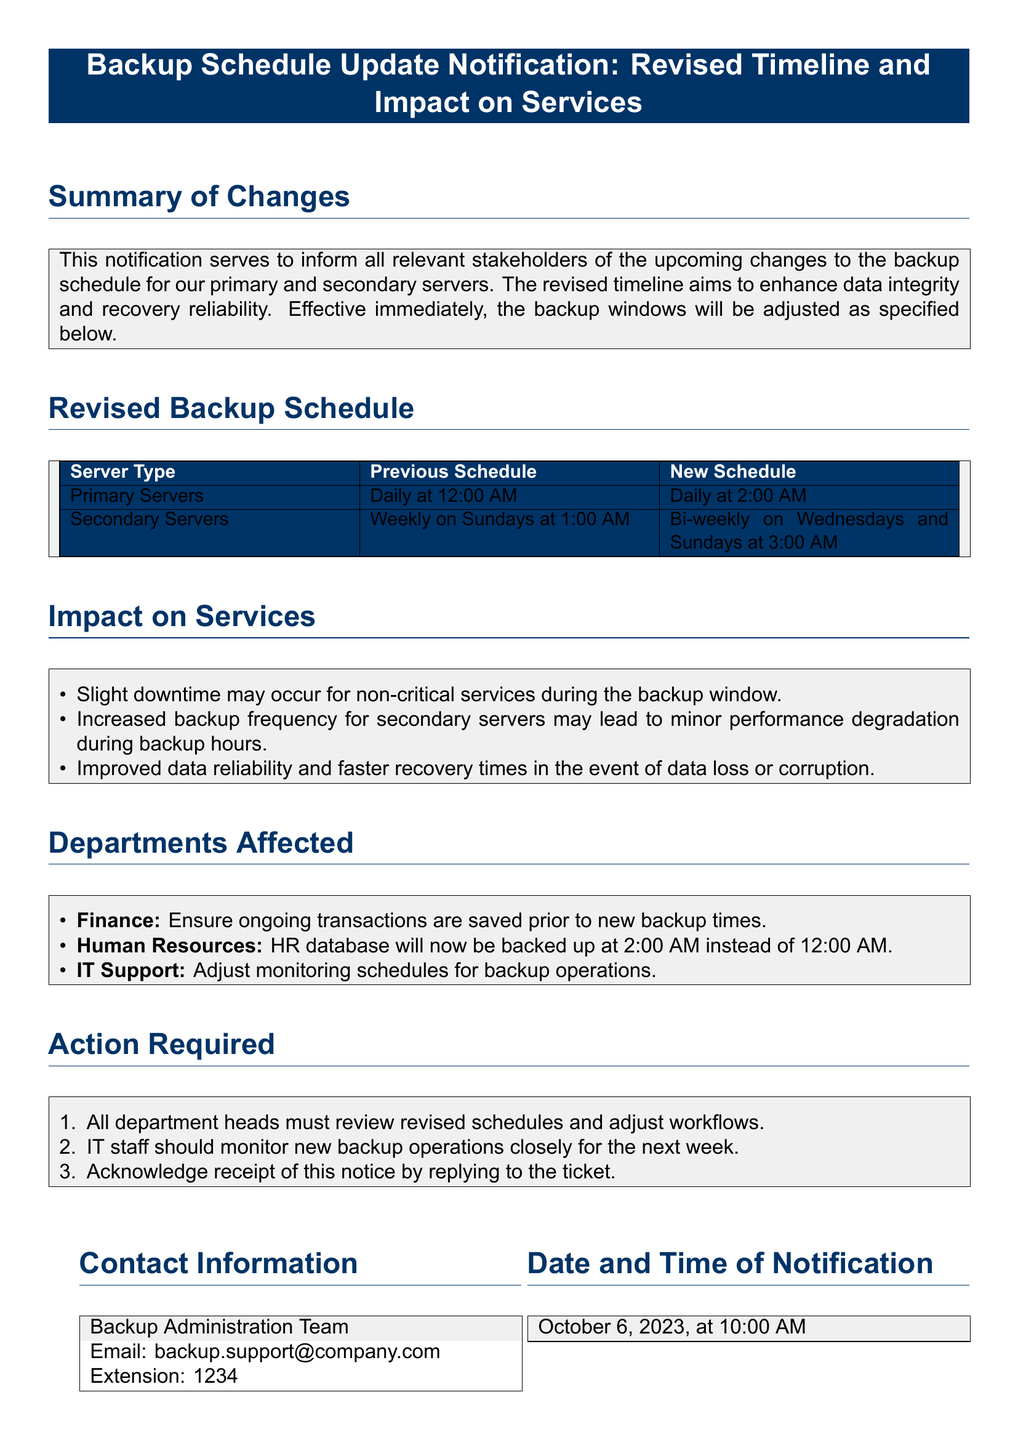What is the new backup time for primary servers? The new backup time for primary servers is adjusted from 12:00 AM to 2:00 AM.
Answer: Daily at 2:00 AM What is the revised backup frequency for secondary servers? Secondary servers will now back up bi-weekly on Wednesdays and Sundays instead of weekly on Sundays.
Answer: Bi-weekly on Wednesdays and Sundays What is the date and time of notification? The notification was issued on October 6, 2023, at 10:00 AM as stated in the document.
Answer: October 6, 2023, at 10:00 AM Which department needs to ensure ongoing transactions are saved? The Finance department is the one that must ensure ongoing transactions are saved prior to the new backup times.
Answer: Finance What is one potential impact on services during the backup window? The document notes slight downtime may occur for non-critical services during the backup window.
Answer: Slight downtime What action must all department heads take? All department heads are required to review the revised schedules and adjust workflows accordingly.
Answer: Review revised schedules and adjust workflows How should IT staff respond to the new backup operations? IT staff should monitor the new backup operations closely for the next week according to the action required section.
Answer: Monitor new backup operations closely What is the purpose of the revised backup schedule? The purpose of the revised backup schedule is to enhance data integrity and recovery reliability.
Answer: Enhance data integrity and recovery reliability What is the contact email for the Backup Administration Team? The document specifies the email for the Backup Administration Team, providing contact information.
Answer: backup.support@company.com 